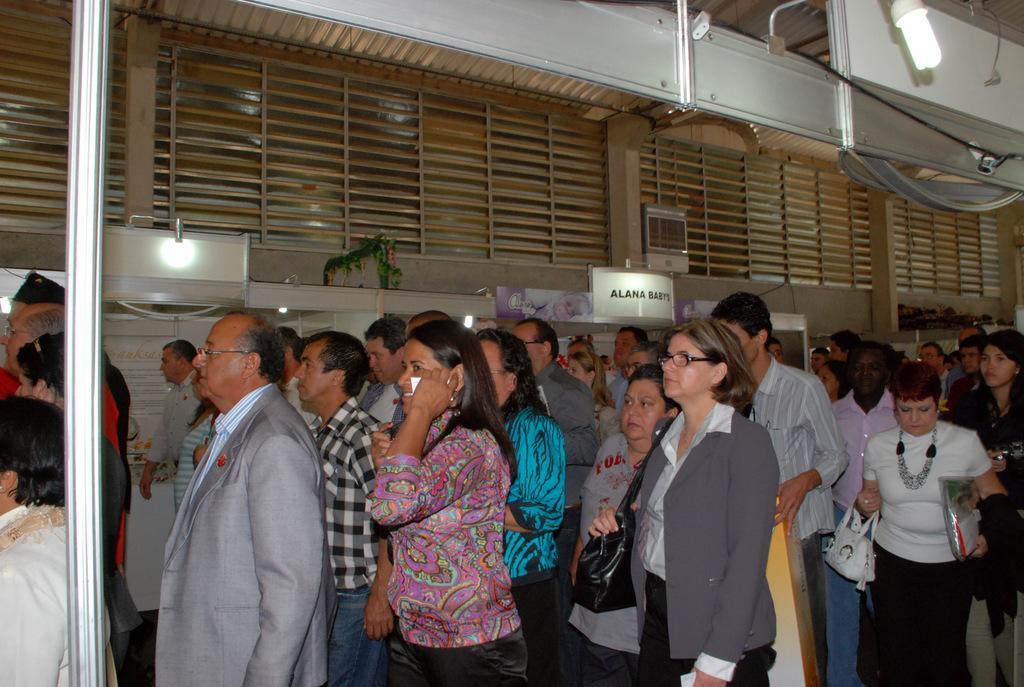Could you give a brief overview of what you see in this image? There are groups of people standing. This looks like a name board, which is attached to the wall. Here is a light. I think these look like the windows. Here is a pole. 